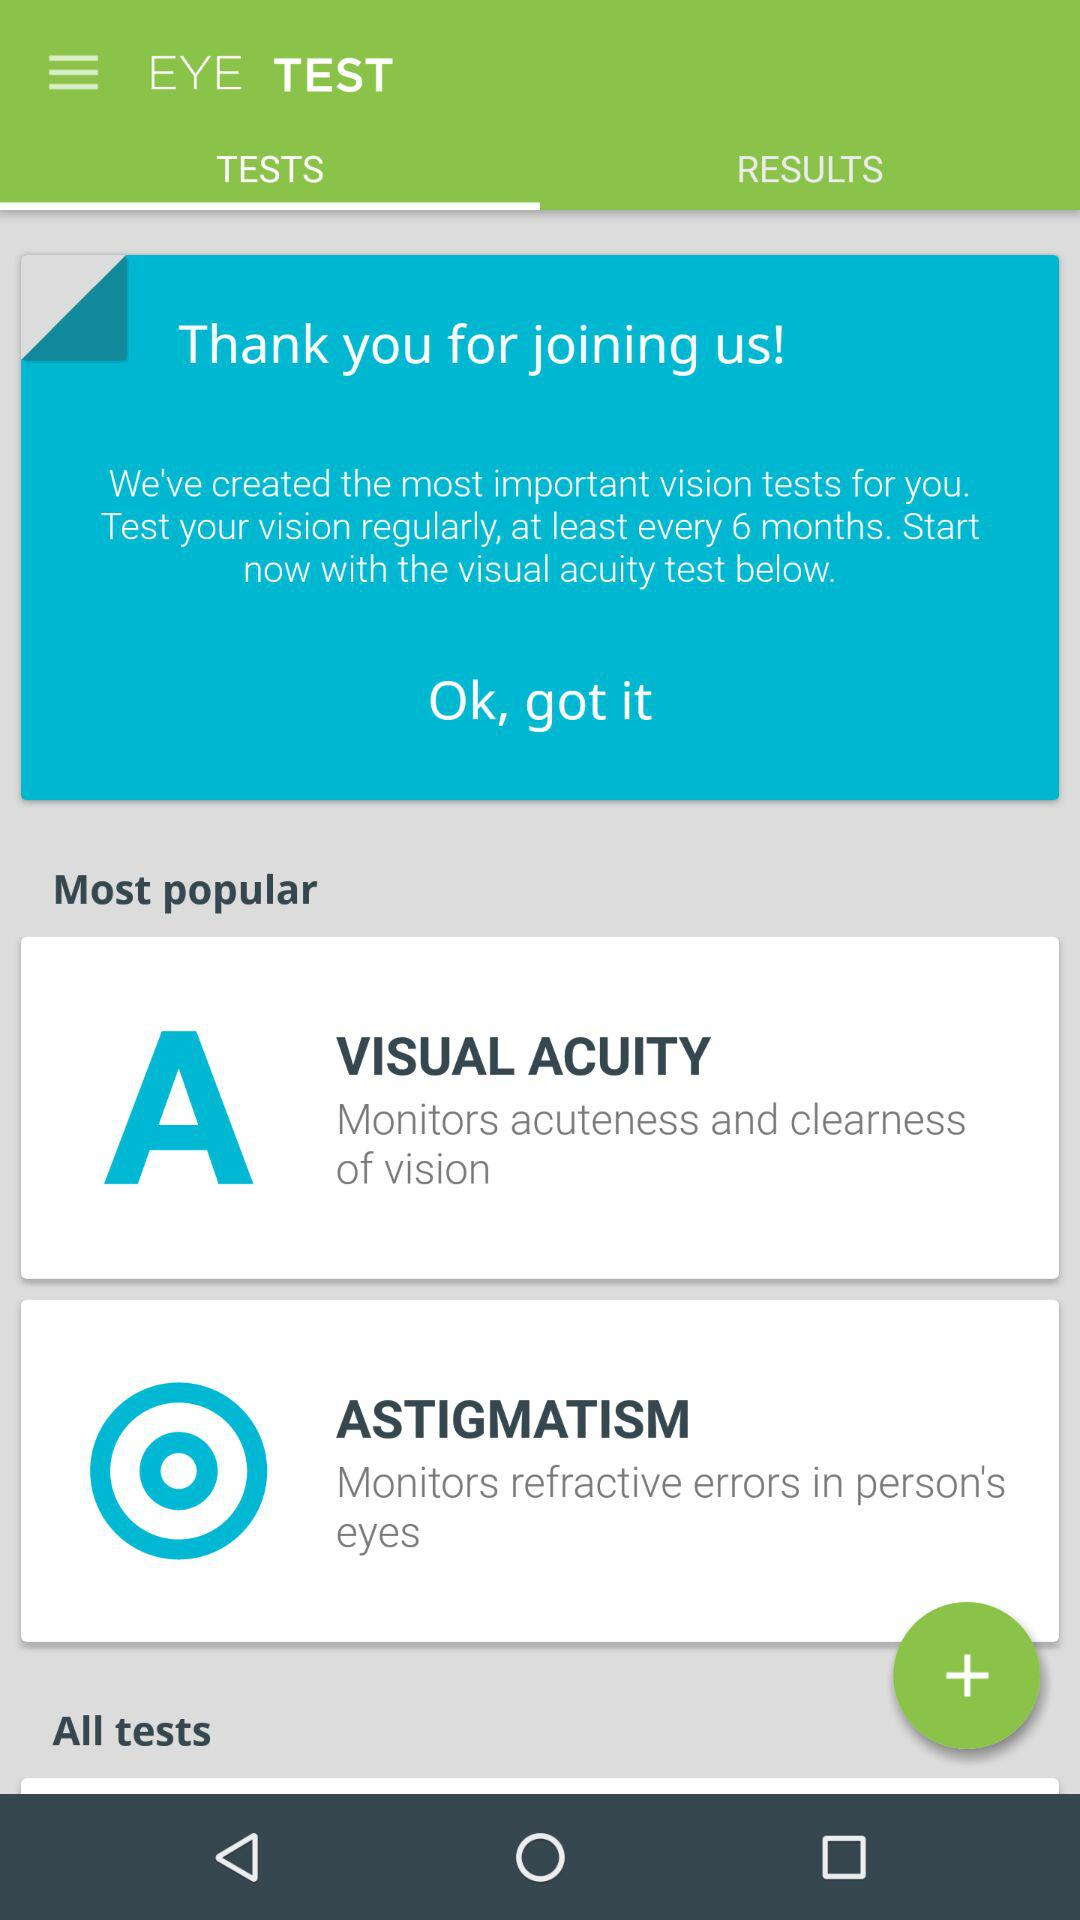Which tests are the most popular? The most popular tests are visual acuity and astigmatism. 